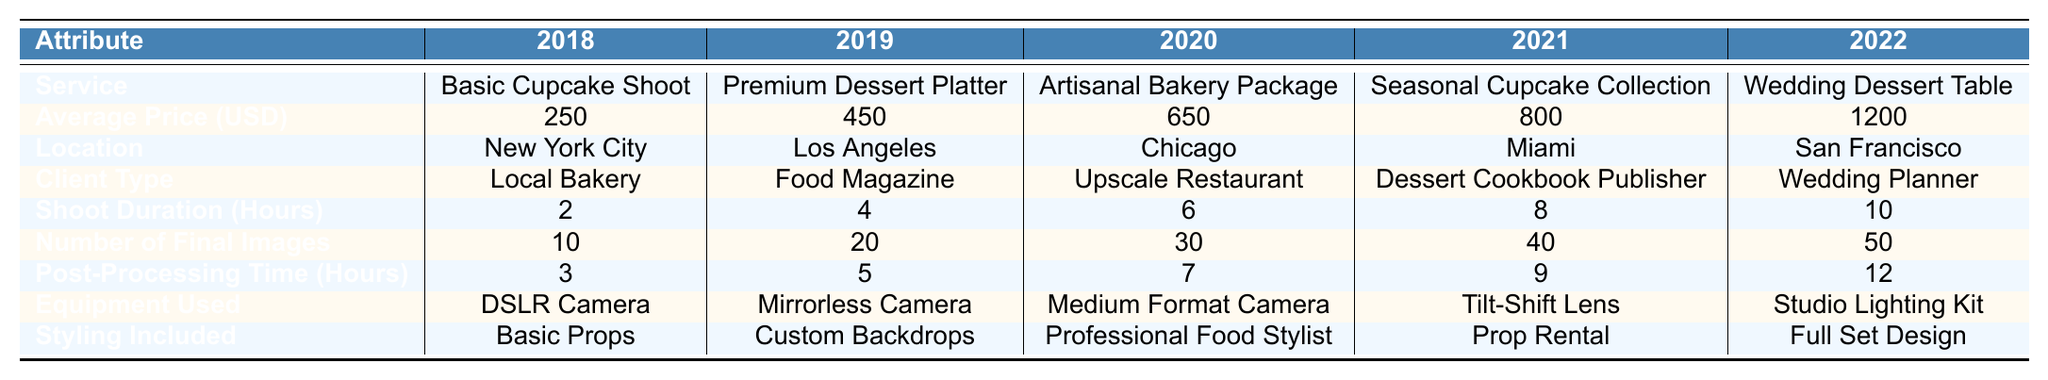What is the average price for the "Wedding Dessert Table" service? The table indicates that the average price for the "Wedding Dessert Table" in 2022 is 1200 USD.
Answer: 1200 USD Which service has the longest shoot duration? By looking at the "Shoot Duration (Hours)" row, the "Wedding Dessert Table" has the longest duration at 10 hours.
Answer: Wedding Dessert Table How many final images are typically produced for the "Artisanal Bakery Package"? The "Number of Final Images" for the "Artisanal Bakery Package" is 30 as per the corresponding row.
Answer: 30 What was the average price increase from 2018 to 2022? The average price in 2018 was 250 USD and in 2022 it was 1200 USD. The increase is 1200 - 250 = 950 USD.
Answer: 950 USD Which location is associated with the "Seasonal Cupcake Collection" service? The "Seasonal Cupcake Collection" is associated with Miami, as indicated in the "Location" row for that service.
Answer: Miami Did the "Basic Cupcake Shoot" service ever exceed 300 USD in price? The average price for the "Basic Cupcake Shoot" in 2018 was 250 USD, which is less than 300 USD. Therefore, it never exceeded 300 USD.
Answer: No What is the total shoot duration for all services combined? The total shoot duration is calculated by summing the values: 2 + 4 + 6 + 8 + 10 = 30 hours.
Answer: 30 hours Which client type corresponds to the "Premium Dessert Platter"? The "Premium Dessert Platter" corresponds to "Food Magazine" as noted in the "Client Type" row.
Answer: Food Magazine How many more post-processing hours does the "Wedding Dessert Table" require than the "Artisanal Bakery Package"? The "Wedding Dessert Table" requires 12 hours and the "Artisanal Bakery Package" requires 7 hours. The difference is 12 - 7 = 5 hours.
Answer: 5 hours Which service has the highest number of final images? Reviewing the "Number of Final Images" row, the "Wedding Dessert Table" has the highest number of final images at 50.
Answer: Wedding Dessert Table 